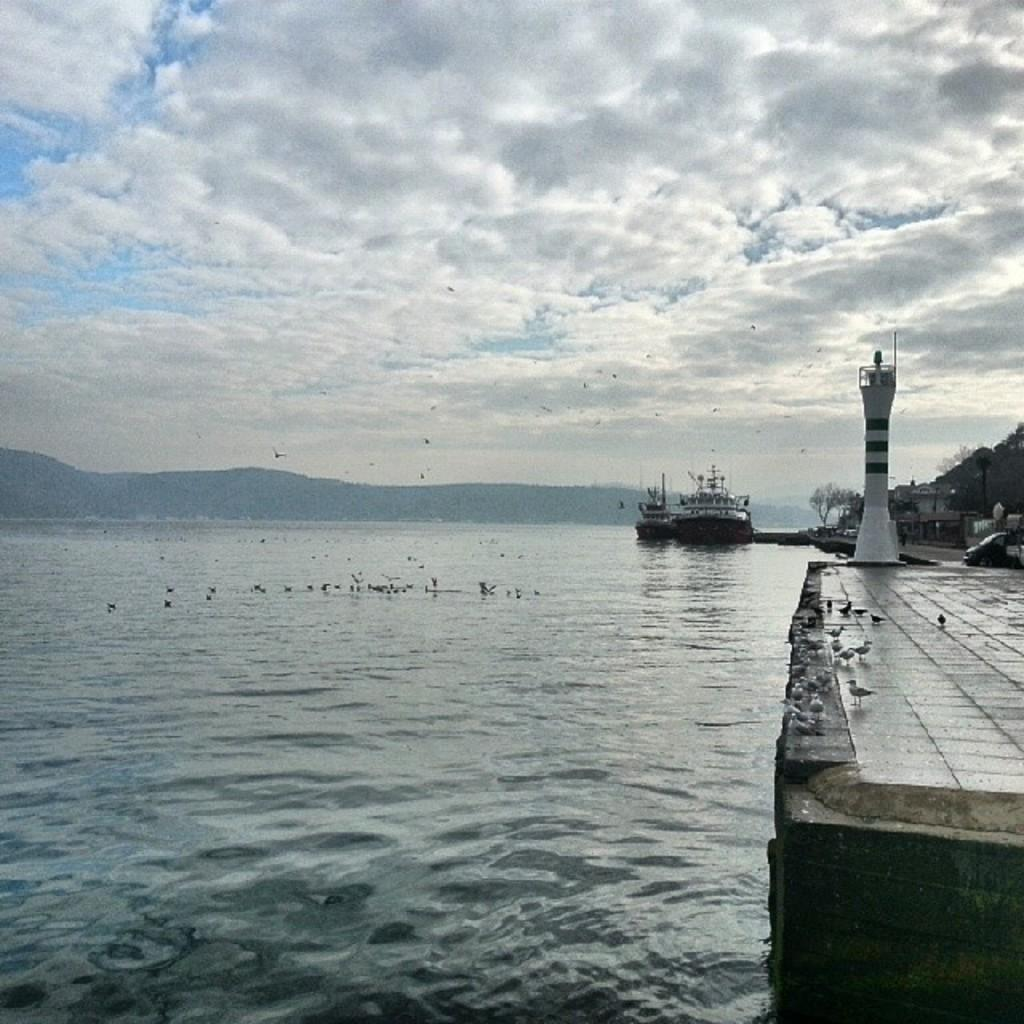What structure is located on the right side of the image? There is a lighthouse on the right side of the image. What body of water is on the left side of the image? There is a river on the left side of the image. What is present on the river in the image? There are boats on the river. What can be seen in the background of the image? There are hills and the sky visible in the background of the image. What type of appliance is being used to detonate a bomb in the image? There is no appliance or bomb present in the image; it features a lighthouse, a river, boats, hills, and the sky. 